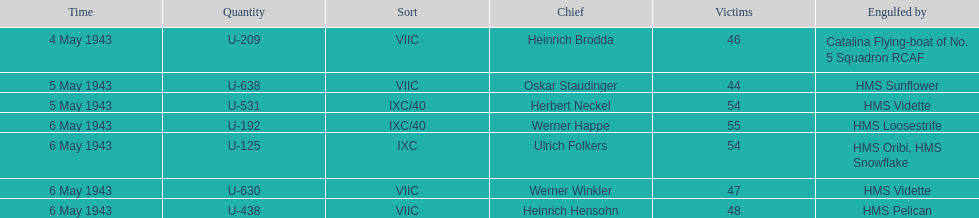How many captains are listed? 7. 